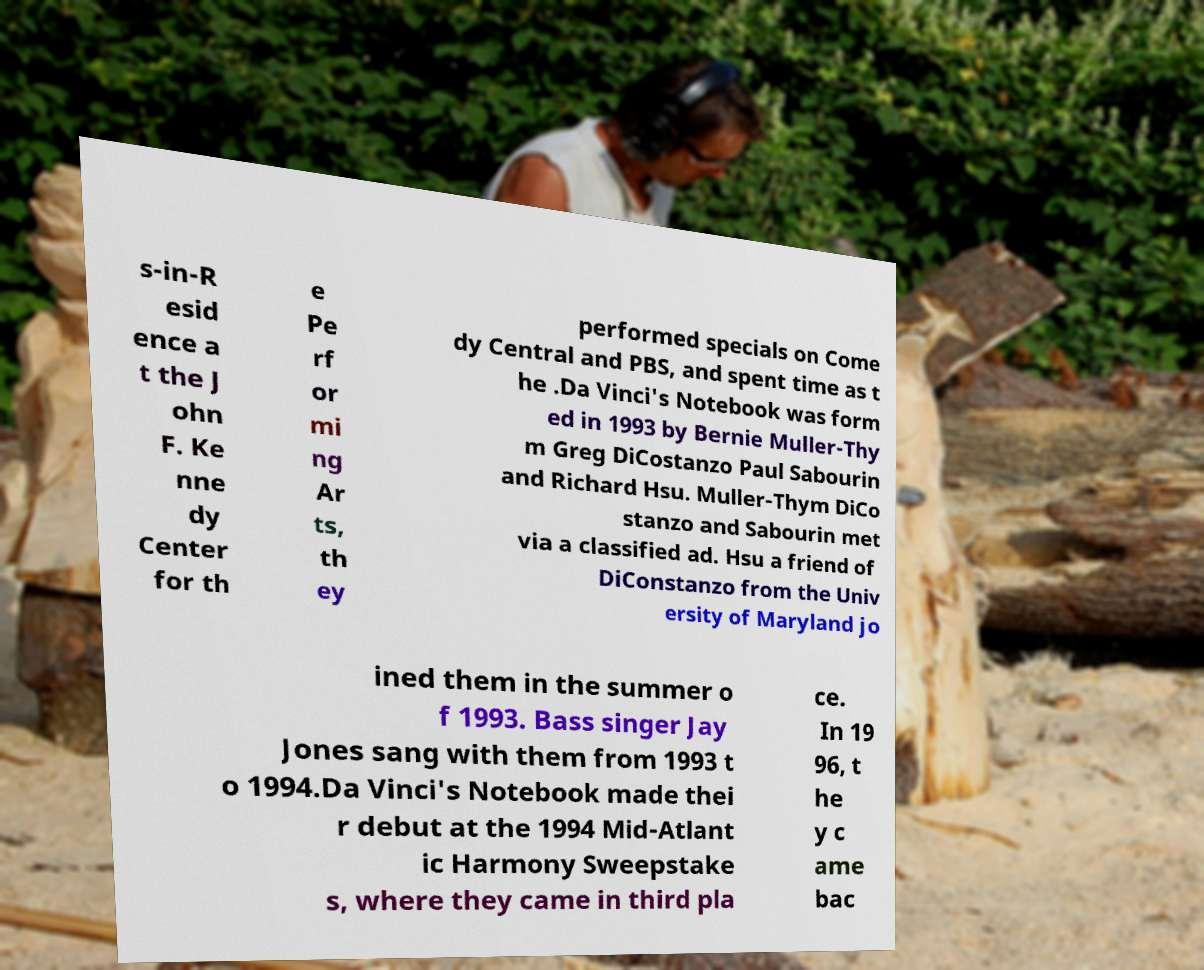For documentation purposes, I need the text within this image transcribed. Could you provide that? s-in-R esid ence a t the J ohn F. Ke nne dy Center for th e Pe rf or mi ng Ar ts, th ey performed specials on Come dy Central and PBS, and spent time as t he .Da Vinci's Notebook was form ed in 1993 by Bernie Muller-Thy m Greg DiCostanzo Paul Sabourin and Richard Hsu. Muller-Thym DiCo stanzo and Sabourin met via a classified ad. Hsu a friend of DiConstanzo from the Univ ersity of Maryland jo ined them in the summer o f 1993. Bass singer Jay Jones sang with them from 1993 t o 1994.Da Vinci's Notebook made thei r debut at the 1994 Mid-Atlant ic Harmony Sweepstake s, where they came in third pla ce. In 19 96, t he y c ame bac 